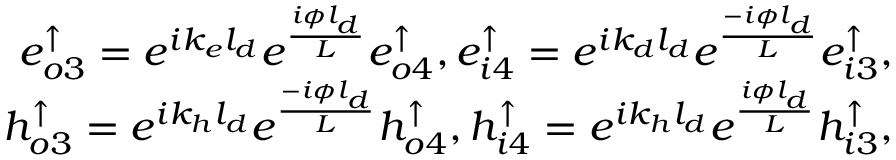<formula> <loc_0><loc_0><loc_500><loc_500>\begin{array} { r } { e _ { o 3 } ^ { \uparrow } = e ^ { i k _ { e } l _ { d } } e ^ { \frac { i \phi l _ { d } } { L } } e _ { o 4 } ^ { \uparrow } , e _ { i 4 } ^ { \uparrow } = e ^ { i k _ { d } l _ { d } } e ^ { \frac { - i \phi l _ { d } } { L } } e _ { i 3 } ^ { \uparrow } , } \\ { h _ { o 3 } ^ { \uparrow } = e ^ { i k _ { h } l _ { d } } e ^ { \frac { - i \phi l _ { d } } { L } } h _ { o 4 } ^ { \uparrow } , h _ { i 4 } ^ { \uparrow } = e ^ { i k _ { h } l _ { d } } e ^ { \frac { i \phi l _ { d } } { L } } h _ { i 3 } ^ { \uparrow } , } \end{array}</formula> 